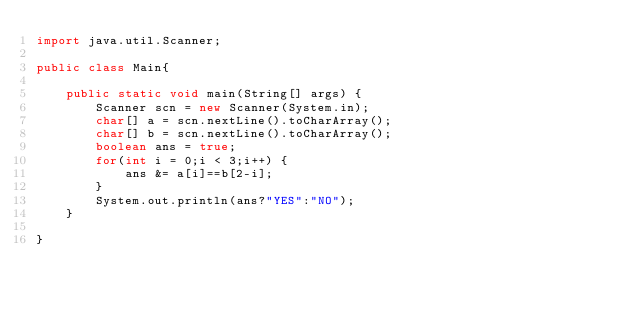Convert code to text. <code><loc_0><loc_0><loc_500><loc_500><_Java_>import java.util.Scanner;

public class Main{

	public static void main(String[] args) {
		Scanner scn = new Scanner(System.in);
		char[] a = scn.nextLine().toCharArray();
		char[] b = scn.nextLine().toCharArray();
		boolean ans = true;
		for(int i = 0;i < 3;i++) {
			ans &= a[i]==b[2-i];
		}
		System.out.println(ans?"YES":"NO");
	}

}
</code> 